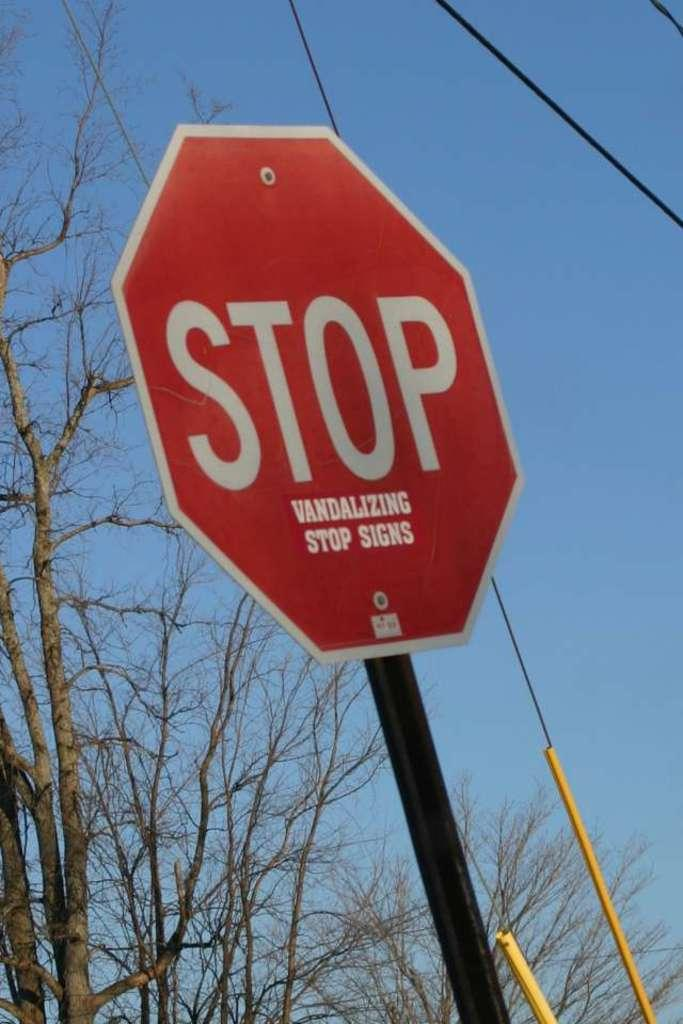<image>
Render a clear and concise summary of the photo. A stop sign that says stop vandalizing stop signs. 